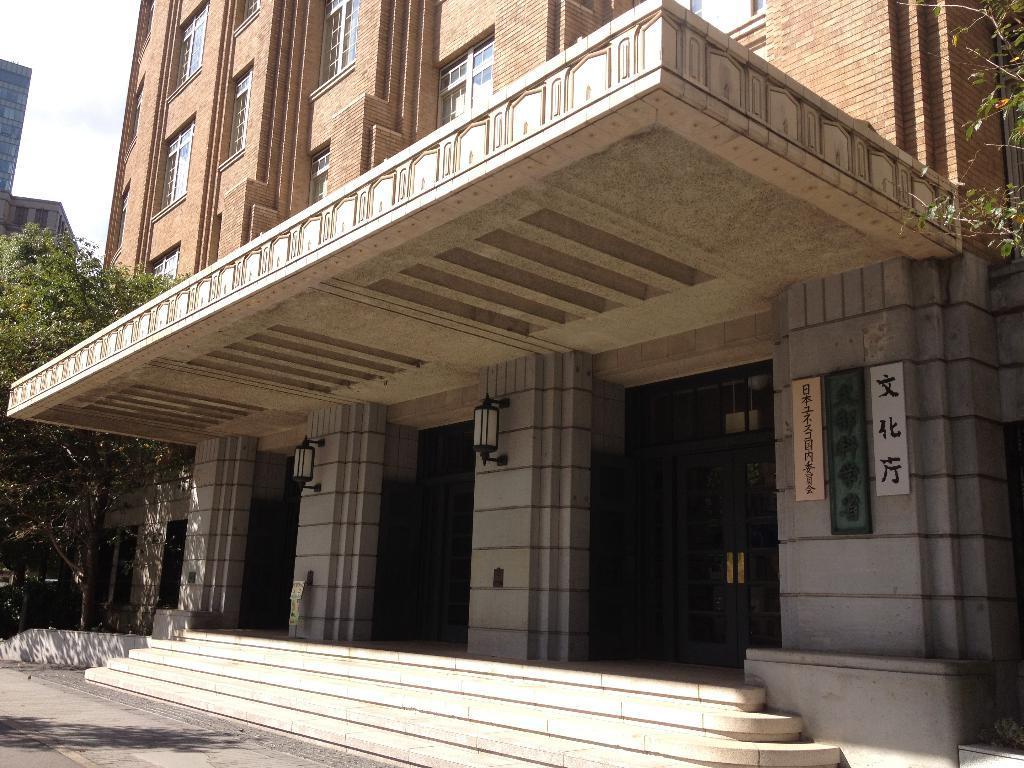In one or two sentences, can you explain what this image depicts? In the image we can see some trees and buildings, on the building we can see some lights and banners. In the top left corner of the image we can see the sky. 